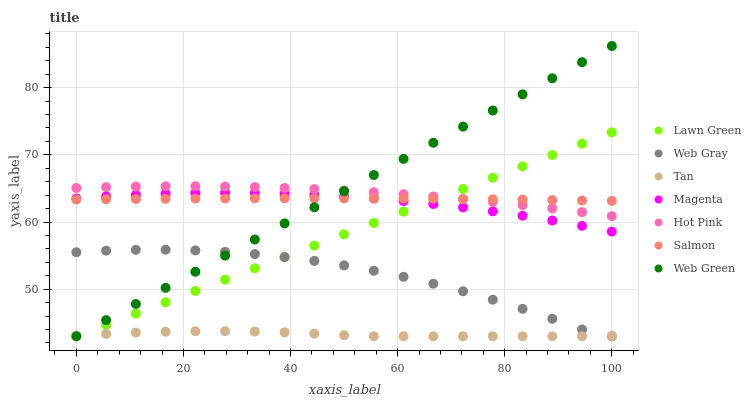Does Tan have the minimum area under the curve?
Answer yes or no. Yes. Does Web Green have the maximum area under the curve?
Answer yes or no. Yes. Does Web Gray have the minimum area under the curve?
Answer yes or no. No. Does Web Gray have the maximum area under the curve?
Answer yes or no. No. Is Lawn Green the smoothest?
Answer yes or no. Yes. Is Web Gray the roughest?
Answer yes or no. Yes. Is Hot Pink the smoothest?
Answer yes or no. No. Is Hot Pink the roughest?
Answer yes or no. No. Does Lawn Green have the lowest value?
Answer yes or no. Yes. Does Hot Pink have the lowest value?
Answer yes or no. No. Does Web Green have the highest value?
Answer yes or no. Yes. Does Web Gray have the highest value?
Answer yes or no. No. Is Web Gray less than Hot Pink?
Answer yes or no. Yes. Is Hot Pink greater than Tan?
Answer yes or no. Yes. Does Tan intersect Web Green?
Answer yes or no. Yes. Is Tan less than Web Green?
Answer yes or no. No. Is Tan greater than Web Green?
Answer yes or no. No. Does Web Gray intersect Hot Pink?
Answer yes or no. No. 